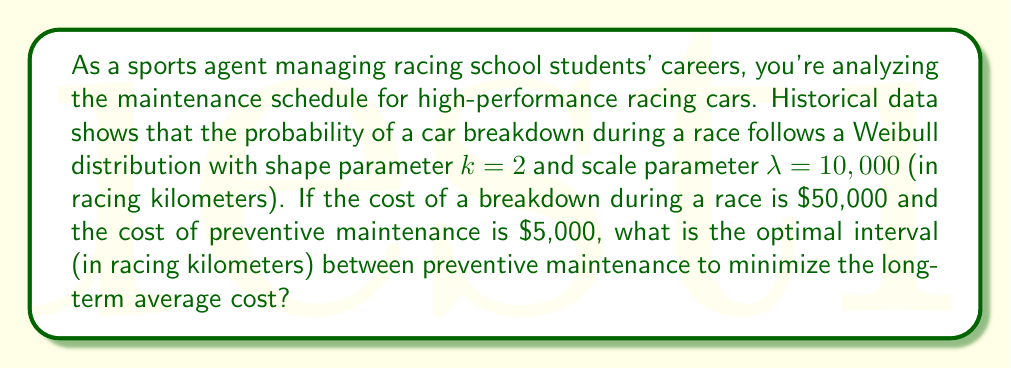Provide a solution to this math problem. To solve this problem, we need to use the concept of renewal-reward processes and the optimal replacement interval formula. The steps are as follows:

1. The Weibull distribution's cumulative distribution function (CDF) is given by:
   $$F(t) = 1 - e^{-(t/\lambda)^k}$$

2. The probability density function (PDF) is the derivative of the CDF:
   $$f(t) = \frac{k}{\lambda} (\frac{t}{\lambda})^{k-1} e^{-(t/\lambda)^k}$$

3. The expected cost per cycle is:
   $$E[C(T)] = C_p + C_f \cdot F(T)$$
   where $C_p$ is the cost of preventive maintenance, $C_f$ is the cost of failure, and $T$ is the maintenance interval.

4. The expected cycle length is:
   $$E[L(T)] = \int_0^T (1 - F(t)) dt$$

5. The long-term average cost per unit time is:
   $$g(T) = \frac{E[C(T)]}{E[L(T)]}$$

6. To minimize $g(T)$, we need to find $T$ where $\frac{d}{dT}g(T) = 0$. This occurs when:
   $$f(T) = \frac{g(T)}{C_f}$$

7. Substituting the given values and solving numerically:
   $$\frac{2}{10000} (\frac{T}{10000})^{2-1} e^{-(T/10000)^2} = \frac{5000 + 50000 \cdot (1 - e^{-(T/10000)^2})}{\int_0^T e^{-(t/10000)^2} dt} \cdot \frac{1}{50000}$$

8. Solving this equation numerically yields $T \approx 7,071$ racing kilometers.
Answer: The optimal interval between preventive maintenance is approximately 7,071 racing kilometers. 